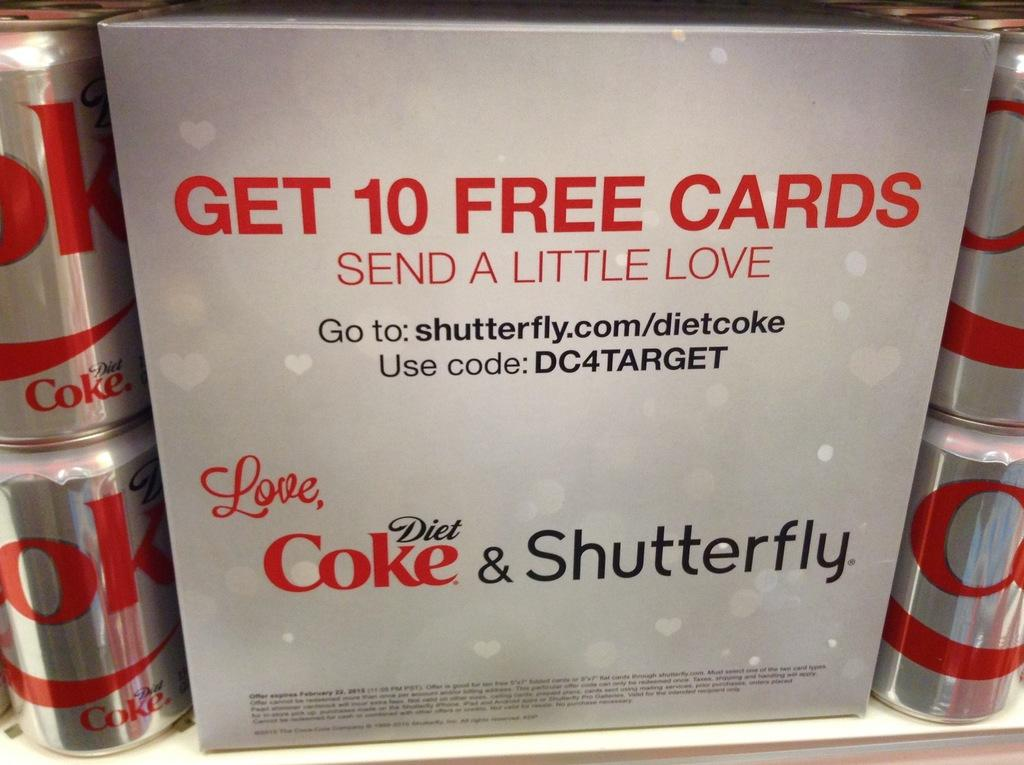<image>
Render a clear and concise summary of the photo. A display of diet cokes telling how to get ten free cards. 